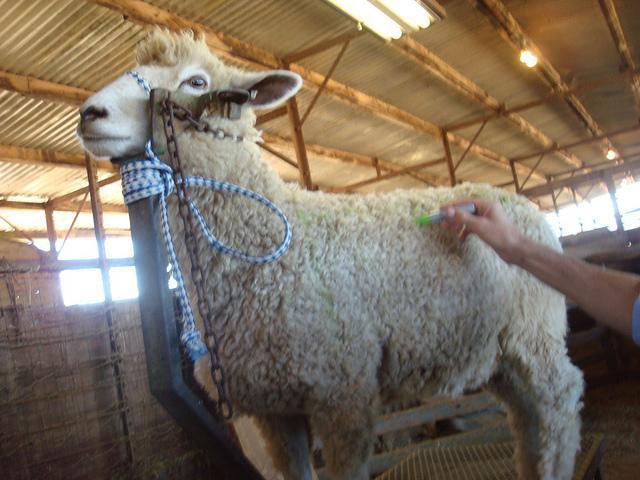Is this affirmation: "The sheep is beneath the person." correct?
Answer yes or no. No. Is "The person is beside the sheep." an appropriate description for the image?
Answer yes or no. Yes. Does the image validate the caption "The sheep is touching the person."?
Answer yes or no. Yes. Is the caption "The person is in front of the sheep." a true representation of the image?
Answer yes or no. No. 